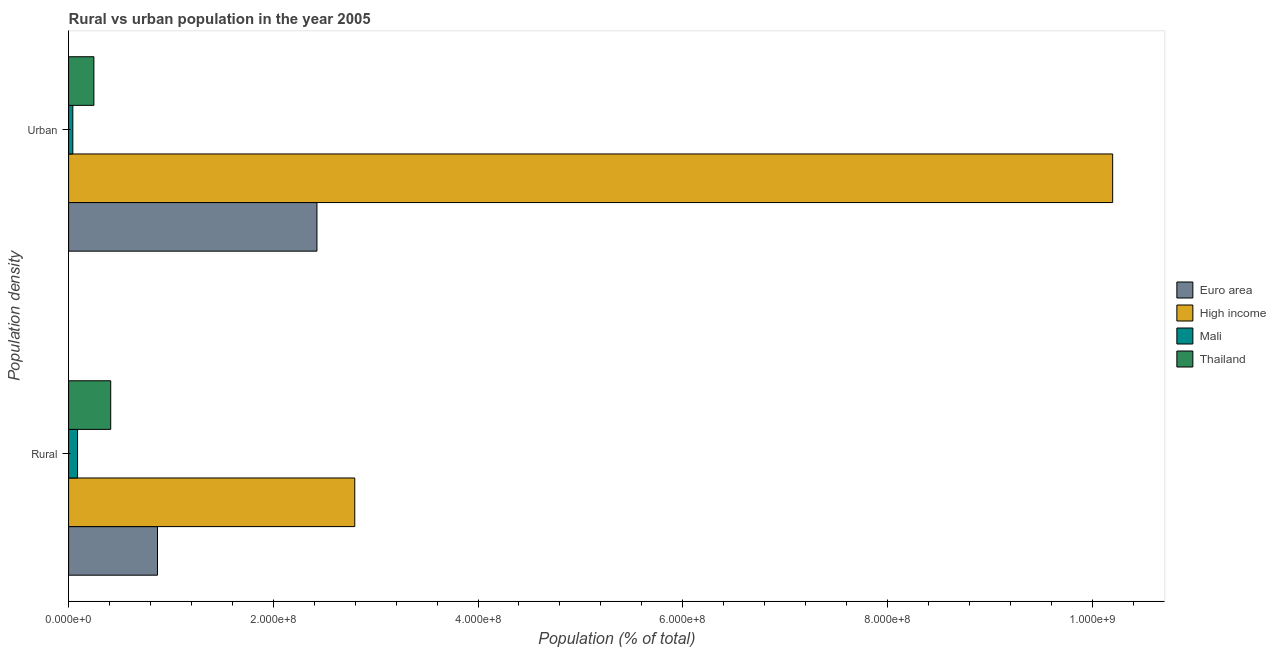How many different coloured bars are there?
Ensure brevity in your answer.  4. How many groups of bars are there?
Your answer should be very brief. 2. How many bars are there on the 2nd tick from the top?
Make the answer very short. 4. What is the label of the 2nd group of bars from the top?
Offer a very short reply. Rural. What is the rural population density in Mali?
Your response must be concise. 8.75e+06. Across all countries, what is the maximum rural population density?
Provide a short and direct response. 2.80e+08. Across all countries, what is the minimum urban population density?
Make the answer very short. 4.13e+06. In which country was the rural population density maximum?
Your answer should be very brief. High income. In which country was the rural population density minimum?
Your answer should be very brief. Mali. What is the total urban population density in the graph?
Offer a terse response. 1.29e+09. What is the difference between the rural population density in Euro area and that in High income?
Provide a short and direct response. -1.93e+08. What is the difference between the rural population density in High income and the urban population density in Mali?
Your answer should be very brief. 2.75e+08. What is the average rural population density per country?
Make the answer very short. 1.04e+08. What is the difference between the rural population density and urban population density in Mali?
Keep it short and to the point. 4.62e+06. In how many countries, is the urban population density greater than 920000000 %?
Provide a short and direct response. 1. What is the ratio of the urban population density in Mali to that in Euro area?
Make the answer very short. 0.02. What does the 4th bar from the bottom in Urban represents?
Offer a terse response. Thailand. How many countries are there in the graph?
Provide a short and direct response. 4. Where does the legend appear in the graph?
Give a very brief answer. Center right. How are the legend labels stacked?
Keep it short and to the point. Vertical. What is the title of the graph?
Keep it short and to the point. Rural vs urban population in the year 2005. Does "Eritrea" appear as one of the legend labels in the graph?
Ensure brevity in your answer.  No. What is the label or title of the X-axis?
Keep it short and to the point. Population (% of total). What is the label or title of the Y-axis?
Give a very brief answer. Population density. What is the Population (% of total) in Euro area in Rural?
Your answer should be compact. 8.68e+07. What is the Population (% of total) in High income in Rural?
Ensure brevity in your answer.  2.80e+08. What is the Population (% of total) in Mali in Rural?
Ensure brevity in your answer.  8.75e+06. What is the Population (% of total) in Thailand in Rural?
Offer a terse response. 4.12e+07. What is the Population (% of total) of Euro area in Urban?
Provide a short and direct response. 2.43e+08. What is the Population (% of total) in High income in Urban?
Your answer should be compact. 1.02e+09. What is the Population (% of total) in Mali in Urban?
Your answer should be compact. 4.13e+06. What is the Population (% of total) in Thailand in Urban?
Give a very brief answer. 2.47e+07. Across all Population density, what is the maximum Population (% of total) of Euro area?
Offer a very short reply. 2.43e+08. Across all Population density, what is the maximum Population (% of total) in High income?
Your answer should be compact. 1.02e+09. Across all Population density, what is the maximum Population (% of total) in Mali?
Offer a terse response. 8.75e+06. Across all Population density, what is the maximum Population (% of total) of Thailand?
Provide a succinct answer. 4.12e+07. Across all Population density, what is the minimum Population (% of total) of Euro area?
Your answer should be compact. 8.68e+07. Across all Population density, what is the minimum Population (% of total) in High income?
Your answer should be very brief. 2.80e+08. Across all Population density, what is the minimum Population (% of total) of Mali?
Offer a very short reply. 4.13e+06. Across all Population density, what is the minimum Population (% of total) in Thailand?
Ensure brevity in your answer.  2.47e+07. What is the total Population (% of total) of Euro area in the graph?
Ensure brevity in your answer.  3.29e+08. What is the total Population (% of total) in High income in the graph?
Offer a terse response. 1.30e+09. What is the total Population (% of total) in Mali in the graph?
Keep it short and to the point. 1.29e+07. What is the total Population (% of total) in Thailand in the graph?
Ensure brevity in your answer.  6.59e+07. What is the difference between the Population (% of total) in Euro area in Rural and that in Urban?
Provide a succinct answer. -1.56e+08. What is the difference between the Population (% of total) in High income in Rural and that in Urban?
Keep it short and to the point. -7.40e+08. What is the difference between the Population (% of total) in Mali in Rural and that in Urban?
Your answer should be compact. 4.62e+06. What is the difference between the Population (% of total) of Thailand in Rural and that in Urban?
Keep it short and to the point. 1.64e+07. What is the difference between the Population (% of total) of Euro area in Rural and the Population (% of total) of High income in Urban?
Offer a very short reply. -9.33e+08. What is the difference between the Population (% of total) in Euro area in Rural and the Population (% of total) in Mali in Urban?
Your answer should be very brief. 8.27e+07. What is the difference between the Population (% of total) in Euro area in Rural and the Population (% of total) in Thailand in Urban?
Offer a terse response. 6.21e+07. What is the difference between the Population (% of total) of High income in Rural and the Population (% of total) of Mali in Urban?
Your response must be concise. 2.75e+08. What is the difference between the Population (% of total) of High income in Rural and the Population (% of total) of Thailand in Urban?
Provide a short and direct response. 2.55e+08. What is the difference between the Population (% of total) of Mali in Rural and the Population (% of total) of Thailand in Urban?
Give a very brief answer. -1.60e+07. What is the average Population (% of total) of Euro area per Population density?
Make the answer very short. 1.65e+08. What is the average Population (% of total) in High income per Population density?
Offer a very short reply. 6.50e+08. What is the average Population (% of total) of Mali per Population density?
Provide a succinct answer. 6.44e+06. What is the average Population (% of total) in Thailand per Population density?
Provide a succinct answer. 3.29e+07. What is the difference between the Population (% of total) in Euro area and Population (% of total) in High income in Rural?
Your answer should be compact. -1.93e+08. What is the difference between the Population (% of total) of Euro area and Population (% of total) of Mali in Rural?
Provide a short and direct response. 7.81e+07. What is the difference between the Population (% of total) in Euro area and Population (% of total) in Thailand in Rural?
Provide a succinct answer. 4.57e+07. What is the difference between the Population (% of total) in High income and Population (% of total) in Mali in Rural?
Provide a succinct answer. 2.71e+08. What is the difference between the Population (% of total) of High income and Population (% of total) of Thailand in Rural?
Offer a terse response. 2.38e+08. What is the difference between the Population (% of total) in Mali and Population (% of total) in Thailand in Rural?
Provide a succinct answer. -3.24e+07. What is the difference between the Population (% of total) in Euro area and Population (% of total) in High income in Urban?
Provide a short and direct response. -7.77e+08. What is the difference between the Population (% of total) in Euro area and Population (% of total) in Mali in Urban?
Give a very brief answer. 2.39e+08. What is the difference between the Population (% of total) in Euro area and Population (% of total) in Thailand in Urban?
Your answer should be compact. 2.18e+08. What is the difference between the Population (% of total) in High income and Population (% of total) in Mali in Urban?
Offer a terse response. 1.02e+09. What is the difference between the Population (% of total) of High income and Population (% of total) of Thailand in Urban?
Your answer should be compact. 9.95e+08. What is the difference between the Population (% of total) in Mali and Population (% of total) in Thailand in Urban?
Your answer should be compact. -2.06e+07. What is the ratio of the Population (% of total) of Euro area in Rural to that in Urban?
Give a very brief answer. 0.36. What is the ratio of the Population (% of total) in High income in Rural to that in Urban?
Give a very brief answer. 0.27. What is the ratio of the Population (% of total) in Mali in Rural to that in Urban?
Ensure brevity in your answer.  2.12. What is the ratio of the Population (% of total) in Thailand in Rural to that in Urban?
Your answer should be very brief. 1.67. What is the difference between the highest and the second highest Population (% of total) in Euro area?
Offer a terse response. 1.56e+08. What is the difference between the highest and the second highest Population (% of total) of High income?
Your answer should be very brief. 7.40e+08. What is the difference between the highest and the second highest Population (% of total) of Mali?
Provide a succinct answer. 4.62e+06. What is the difference between the highest and the second highest Population (% of total) of Thailand?
Your answer should be very brief. 1.64e+07. What is the difference between the highest and the lowest Population (% of total) in Euro area?
Ensure brevity in your answer.  1.56e+08. What is the difference between the highest and the lowest Population (% of total) in High income?
Your answer should be very brief. 7.40e+08. What is the difference between the highest and the lowest Population (% of total) in Mali?
Offer a terse response. 4.62e+06. What is the difference between the highest and the lowest Population (% of total) in Thailand?
Make the answer very short. 1.64e+07. 